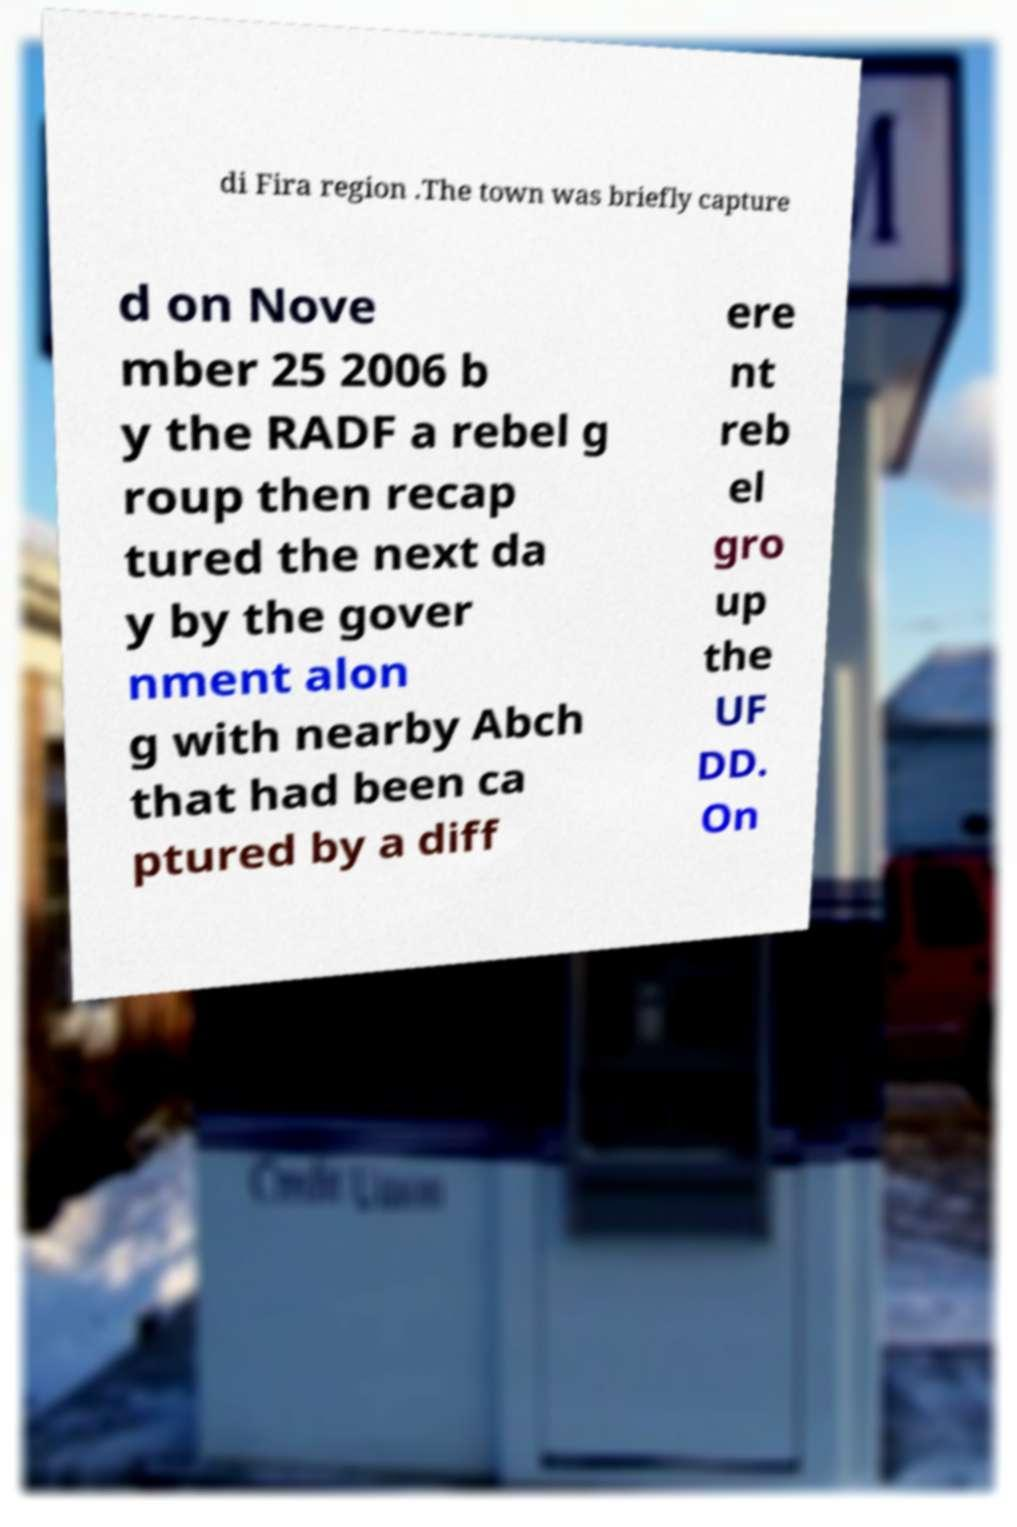I need the written content from this picture converted into text. Can you do that? di Fira region .The town was briefly capture d on Nove mber 25 2006 b y the RADF a rebel g roup then recap tured the next da y by the gover nment alon g with nearby Abch that had been ca ptured by a diff ere nt reb el gro up the UF DD. On 